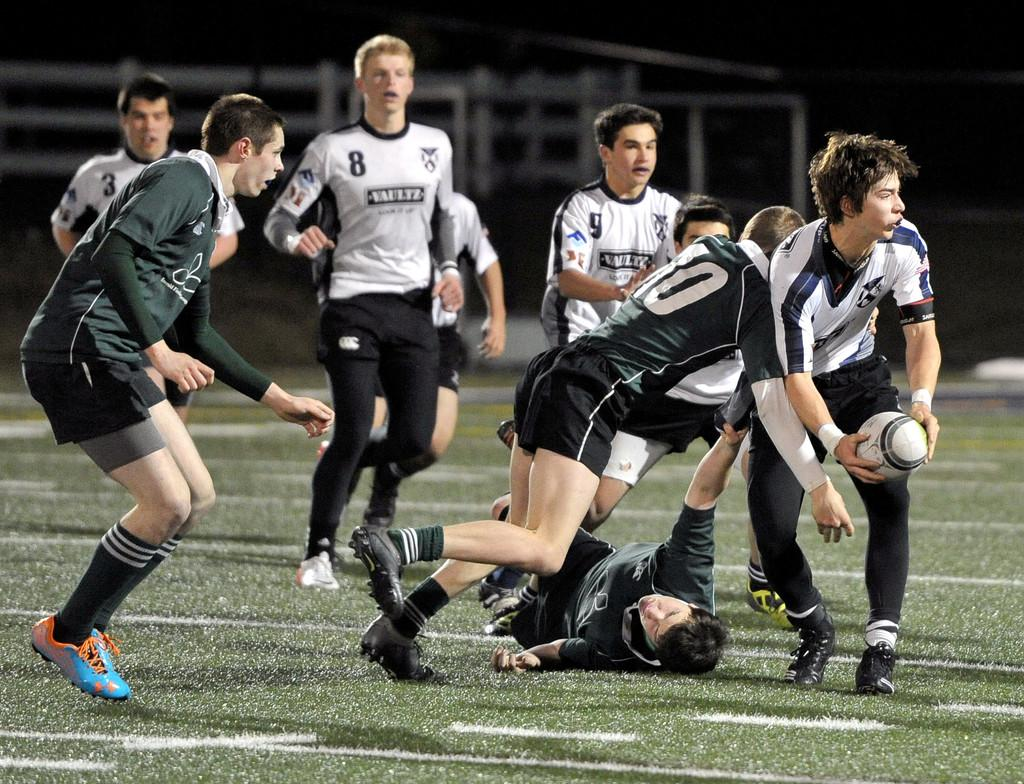What are the people in the image doing? The people in the image are playing in the center. What type of surface can be seen at the bottom of the image? There is grass at the bottom of the image. What degree of heat is being emitted by the grass in the image? There is no indication of heat or temperature in the image, and grass does not emit heat. 